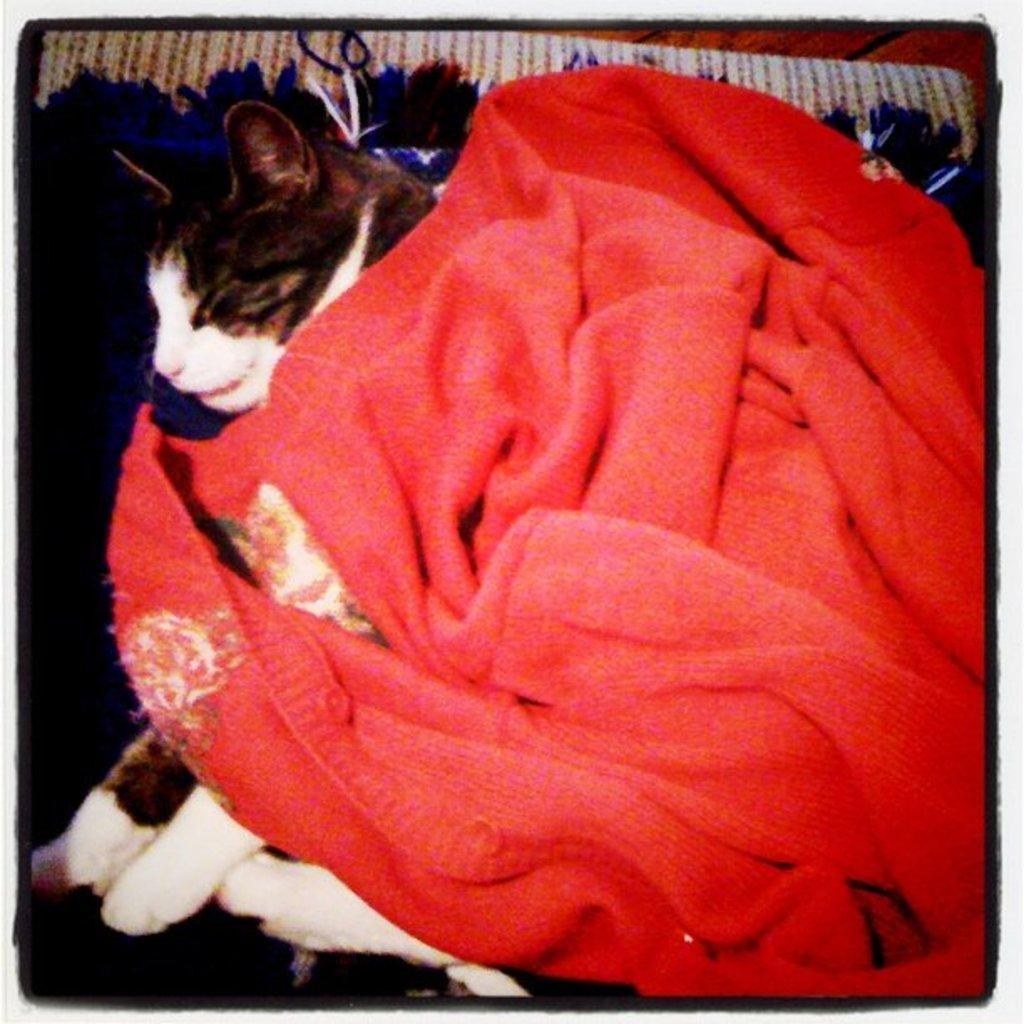In one or two sentences, can you explain what this image depicts? In this image, we can see a cat and a cloth on the tray. 